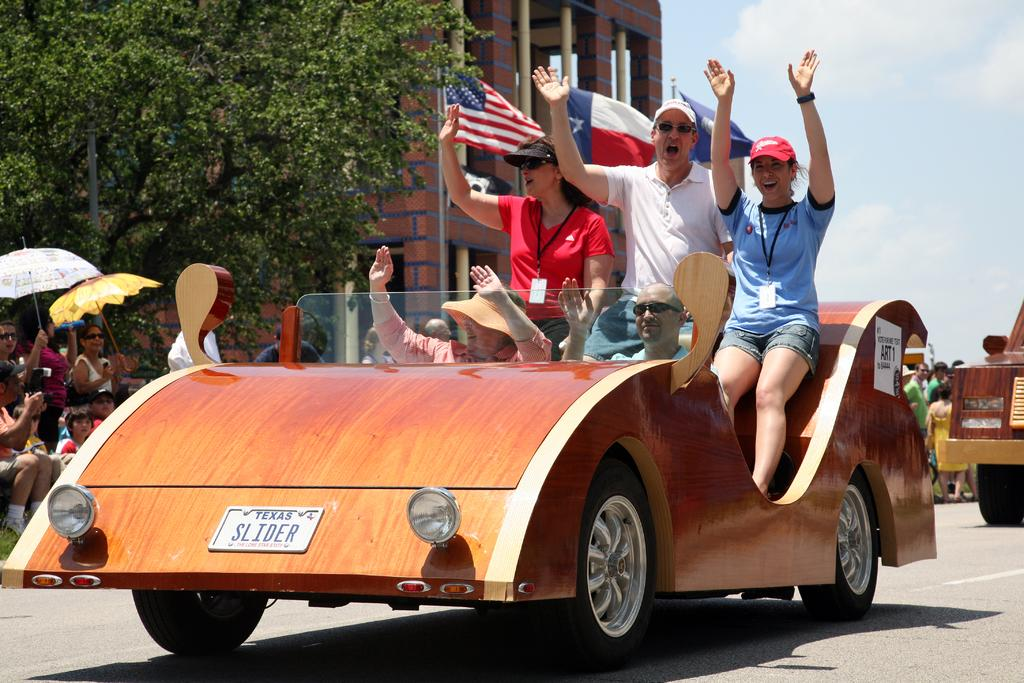What is the main subject of the image? The main subject of the image is a car. Who or what is inside the car? People are sitting inside the car. What can be seen in the background of the image? There are trees visible in the image. What are the other people in the image doing? Other people are sitting and watching the car. What material is the car made of? The car appears to be made of wood. What type of brass instrument is being played by the people sitting inside the car? There is no brass instrument being played by the people inside the car; they are sitting in a wooden car. What shape is the brick used to build the car? There is no brick used to build the car; it is made of wood. 